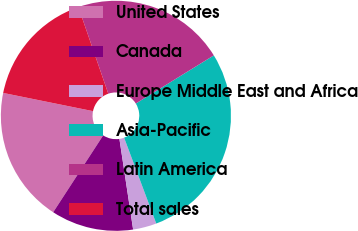Convert chart to OTSL. <chart><loc_0><loc_0><loc_500><loc_500><pie_chart><fcel>United States<fcel>Canada<fcel>Europe Middle East and Africa<fcel>Asia-Pacific<fcel>Latin America<fcel>Total sales<nl><fcel>19.01%<fcel>11.57%<fcel>3.31%<fcel>28.1%<fcel>21.49%<fcel>16.53%<nl></chart> 